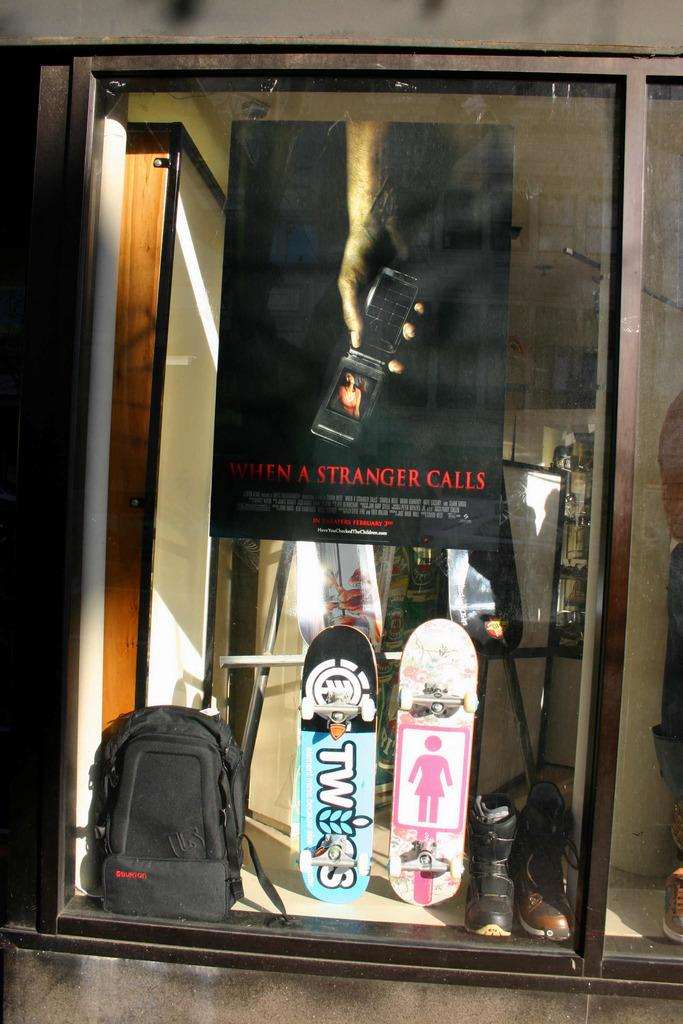What items are on the shelf in the image? There are shoes, skateboards, and a bag on the shelf. Can you describe the types of items on the shelf? The items on the shelf include shoes, skateboards, and a bag. What might the purpose of the bag be on the shelf? The bag on the shelf might be used for carrying or storing items. What type of border is depicted in the image? There is no border present in the image; it features a shelf with shoes, skateboards, and a bag. What attraction can be seen in the background of the image? There is no background or attraction visible in the image; it focuses on the shelf and its contents. 